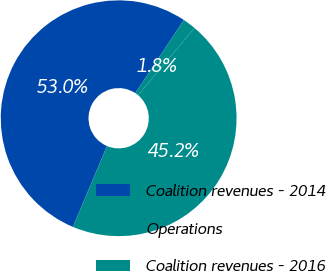Convert chart to OTSL. <chart><loc_0><loc_0><loc_500><loc_500><pie_chart><fcel>Coalition revenues - 2014<fcel>Operations<fcel>Coalition revenues - 2016<nl><fcel>52.99%<fcel>1.8%<fcel>45.21%<nl></chart> 